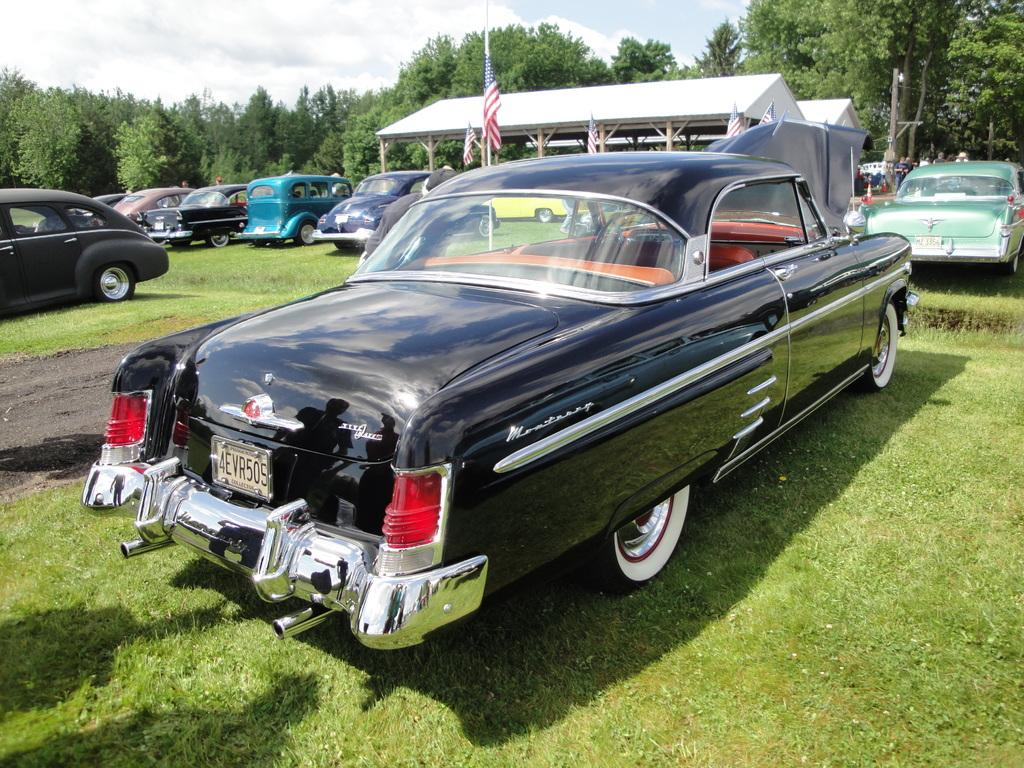What is located on the grass in the image? There are vehicles on the grass in the image. What can be seen in the background of the image? In the background of the image, there are flags, a shed, many trees, clouds, and the sky. How many elements can be identified in the background of the image? There are five elements in the background of the image: flags, a shed, trees, clouds, and the sky. What type of hairstyle does the lead vehicle have in the image? There is no indication of a lead vehicle or any hairstyle in the image; it features vehicles on the grass and various elements in the background. 